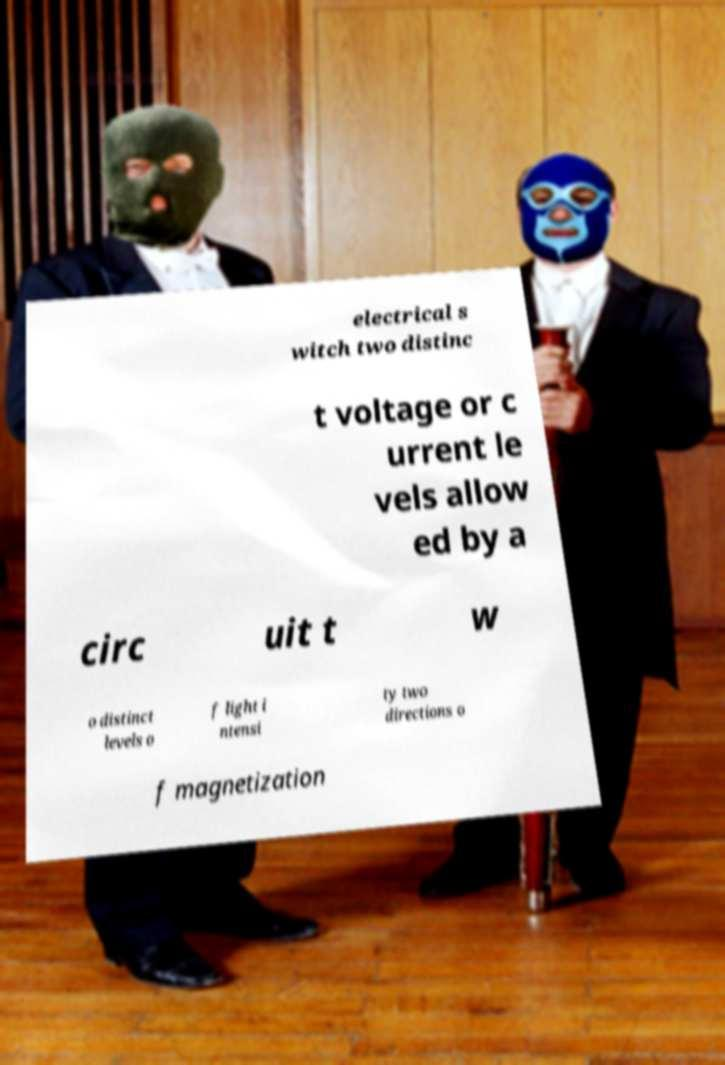Please identify and transcribe the text found in this image. electrical s witch two distinc t voltage or c urrent le vels allow ed by a circ uit t w o distinct levels o f light i ntensi ty two directions o f magnetization 